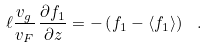<formula> <loc_0><loc_0><loc_500><loc_500>\ell \frac { v _ { g } } { v _ { F } } \, \frac { \partial f _ { 1 } } { \partial z } = - \left ( f _ { 1 } - \left < f _ { 1 } \right > \right ) \ .</formula> 